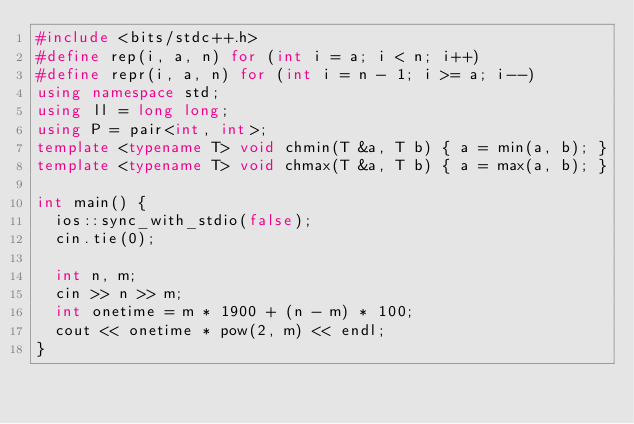<code> <loc_0><loc_0><loc_500><loc_500><_C++_>#include <bits/stdc++.h>
#define rep(i, a, n) for (int i = a; i < n; i++)
#define repr(i, a, n) for (int i = n - 1; i >= a; i--)
using namespace std;
using ll = long long;
using P = pair<int, int>;
template <typename T> void chmin(T &a, T b) { a = min(a, b); }
template <typename T> void chmax(T &a, T b) { a = max(a, b); }

int main() {
  ios::sync_with_stdio(false);
  cin.tie(0);

  int n, m;
  cin >> n >> m;
  int onetime = m * 1900 + (n - m) * 100;
  cout << onetime * pow(2, m) << endl;
}
</code> 